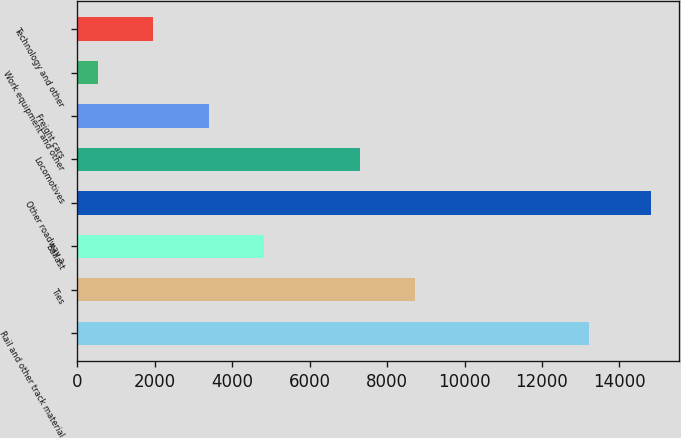<chart> <loc_0><loc_0><loc_500><loc_500><bar_chart><fcel>Rail and other track material<fcel>Ties<fcel>Ballast<fcel>Other roadway a<fcel>Locomotives<fcel>Freight cars<fcel>Work equipment and other<fcel>Technology and other<nl><fcel>13220<fcel>8724.1<fcel>4816.3<fcel>14806<fcel>7297<fcel>3389.2<fcel>535<fcel>1962.1<nl></chart> 